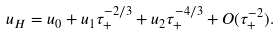<formula> <loc_0><loc_0><loc_500><loc_500>u _ { H } = u _ { 0 } + u _ { 1 } \tau _ { + } ^ { - 2 / 3 } + u _ { 2 } \tau _ { + } ^ { - 4 / 3 } + O ( \tau _ { + } ^ { - 2 } ) .</formula> 